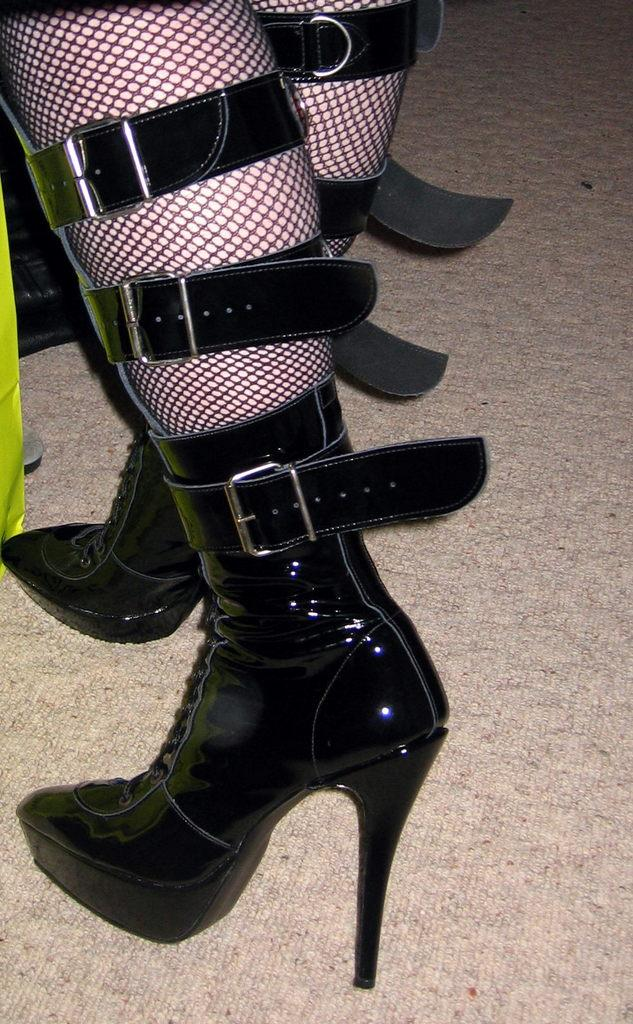What is the main subject of the image? There is a woman in the image. What type of footwear is the woman wearing? The woman is wearing sandals. What color are the sandals? The sandals are black in color. How many clovers can be seen growing near the woman's feet in the image? There are no clovers visible in the image. Is the woman inviting others to join her in the image? The image does not provide any information about the woman inviting others to join her. 